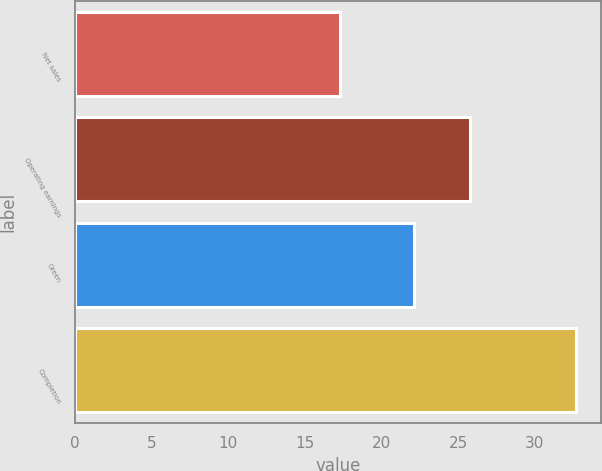Convert chart. <chart><loc_0><loc_0><loc_500><loc_500><bar_chart><fcel>Net sales<fcel>Operating earnings<fcel>Green<fcel>Completion<nl><fcel>17.3<fcel>25.8<fcel>22.1<fcel>32.7<nl></chart> 